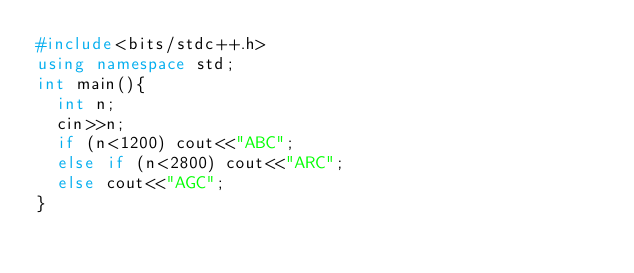Convert code to text. <code><loc_0><loc_0><loc_500><loc_500><_C++_>#include<bits/stdc++.h>
using namespace std;
int main(){
  int n;
  cin>>n;
  if (n<1200) cout<<"ABC";
  else if (n<2800) cout<<"ARC";
  else cout<<"AGC";
}</code> 